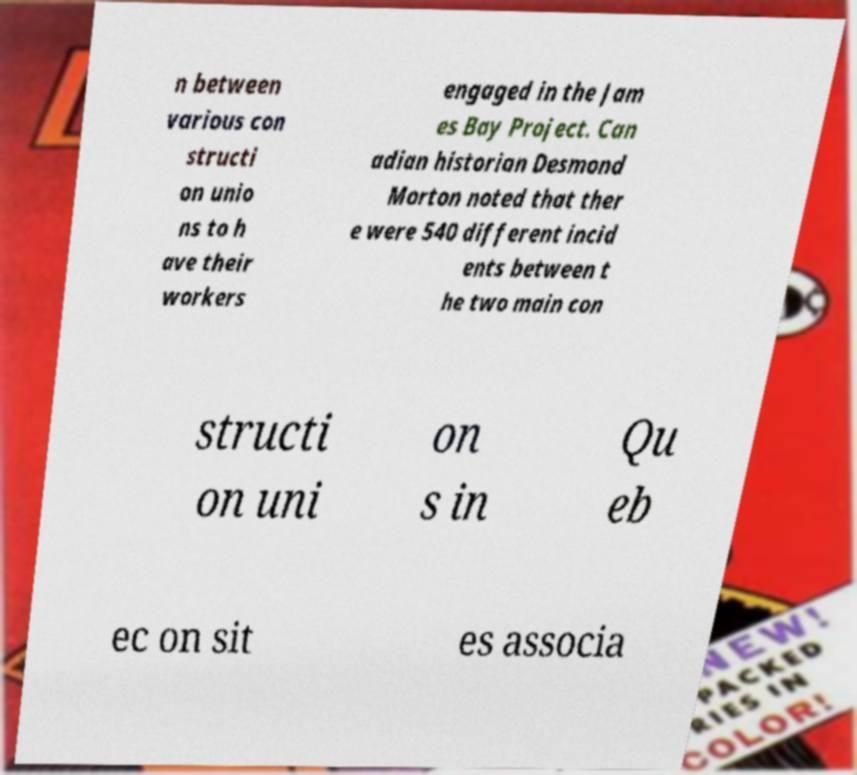I need the written content from this picture converted into text. Can you do that? n between various con structi on unio ns to h ave their workers engaged in the Jam es Bay Project. Can adian historian Desmond Morton noted that ther e were 540 different incid ents between t he two main con structi on uni on s in Qu eb ec on sit es associa 